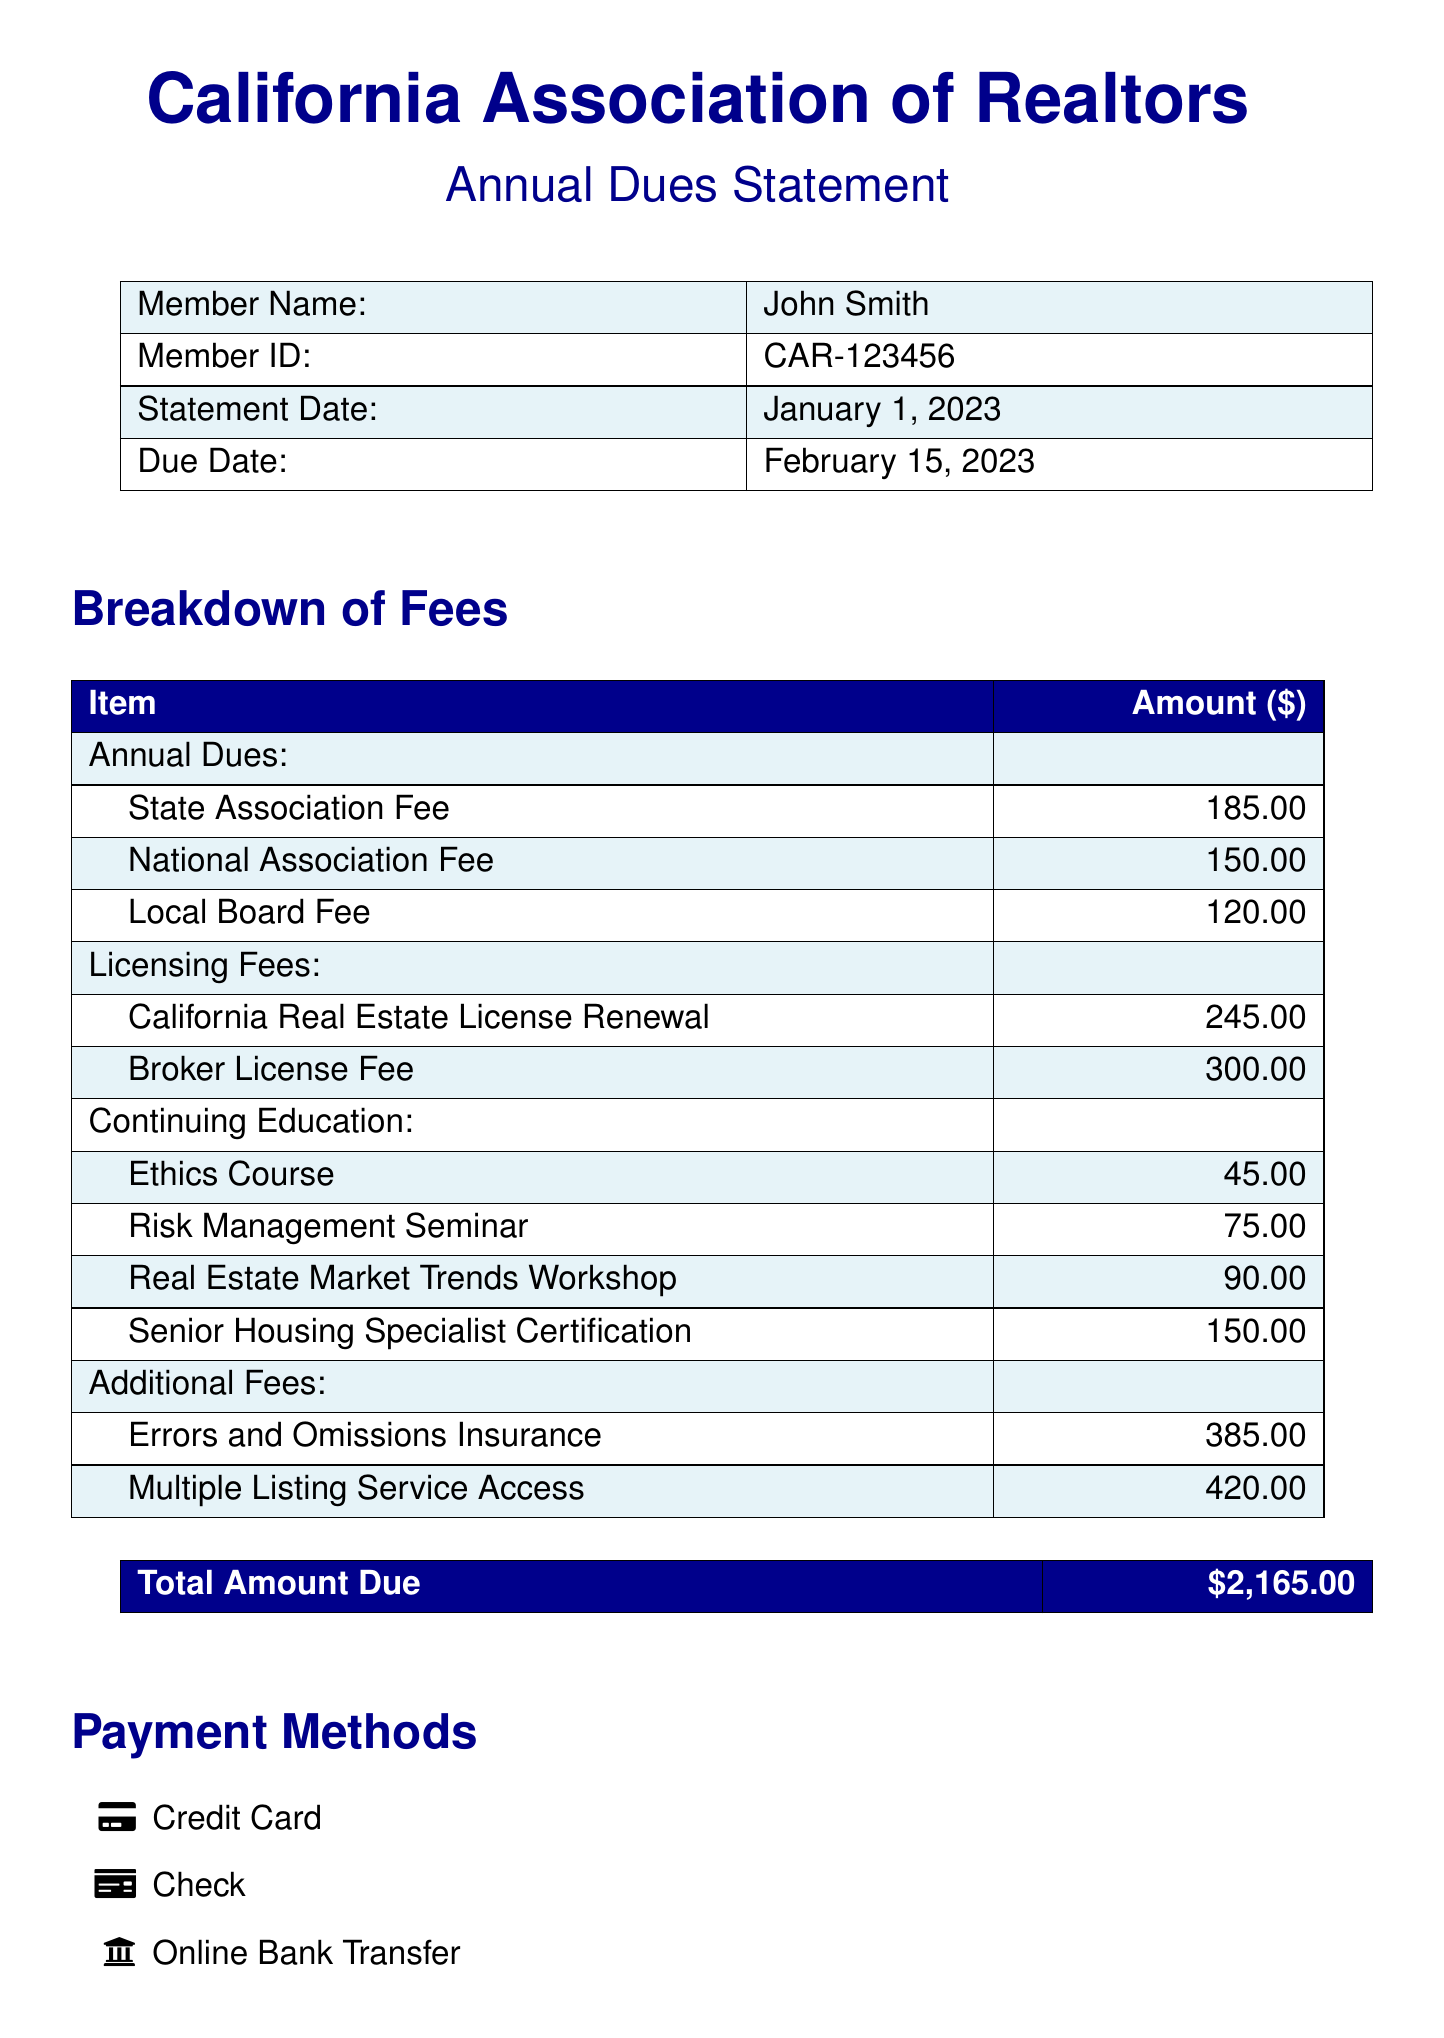What is the member name? The member name is listed at the top of the document.
Answer: John Smith What is the total amount due? The total amount due is presented in the last section of the document.
Answer: $2,165.00 What is the due date? The due date is specified in the header section of the document.
Answer: February 15, 2023 How much is the National Association Fee? The National Association Fee is detailed under the breakdown of fees.
Answer: 150.00 What course costs $90.00? The course amount of $90.00 is specified in the continuing education section.
Answer: Real Estate Market Trends Workshop What is the amount for Errors and Omissions Insurance? This amount is listed in the additional fees section of the document.
Answer: 385.00 What payment methods are available? The payment methods are outlined in a bullet list at the end of the document.
Answer: Credit Card, Check, Online Bank Transfer How many courses are listed under Continuing Education? The number of courses can be counted in the continuing education section.
Answer: 4 What is the California Real Estate License Renewal fee? The fee is provided in the breakdown under licensing fees.
Answer: 245.00 